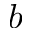Convert formula to latex. <formula><loc_0><loc_0><loc_500><loc_500>b</formula> 